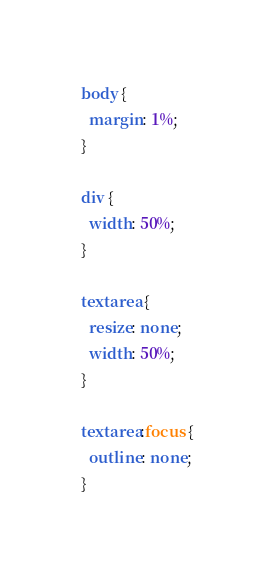Convert code to text. <code><loc_0><loc_0><loc_500><loc_500><_CSS_>body {
  margin: 1%;
}

div {
  width: 50%;
}

textarea {
  resize: none;
  width: 50%;
}

textarea:focus {
  outline: none;
}
</code> 